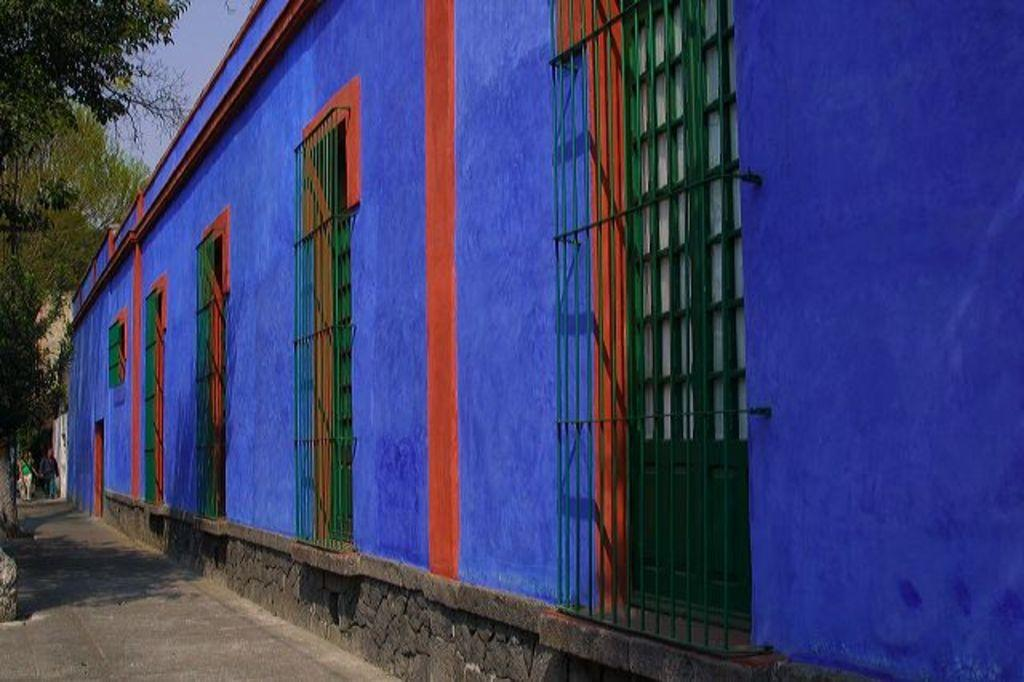What is the color of the building in the image? The building in the image is blue. Where are the persons located in the image? The persons are on the left side of the image. What else can be seen on the left side of the image? There are trees on the left side of the image. Is the image promoting a message of peace? The image does not convey any specific message, including peace, as it only shows a blue building, persons, and trees. 